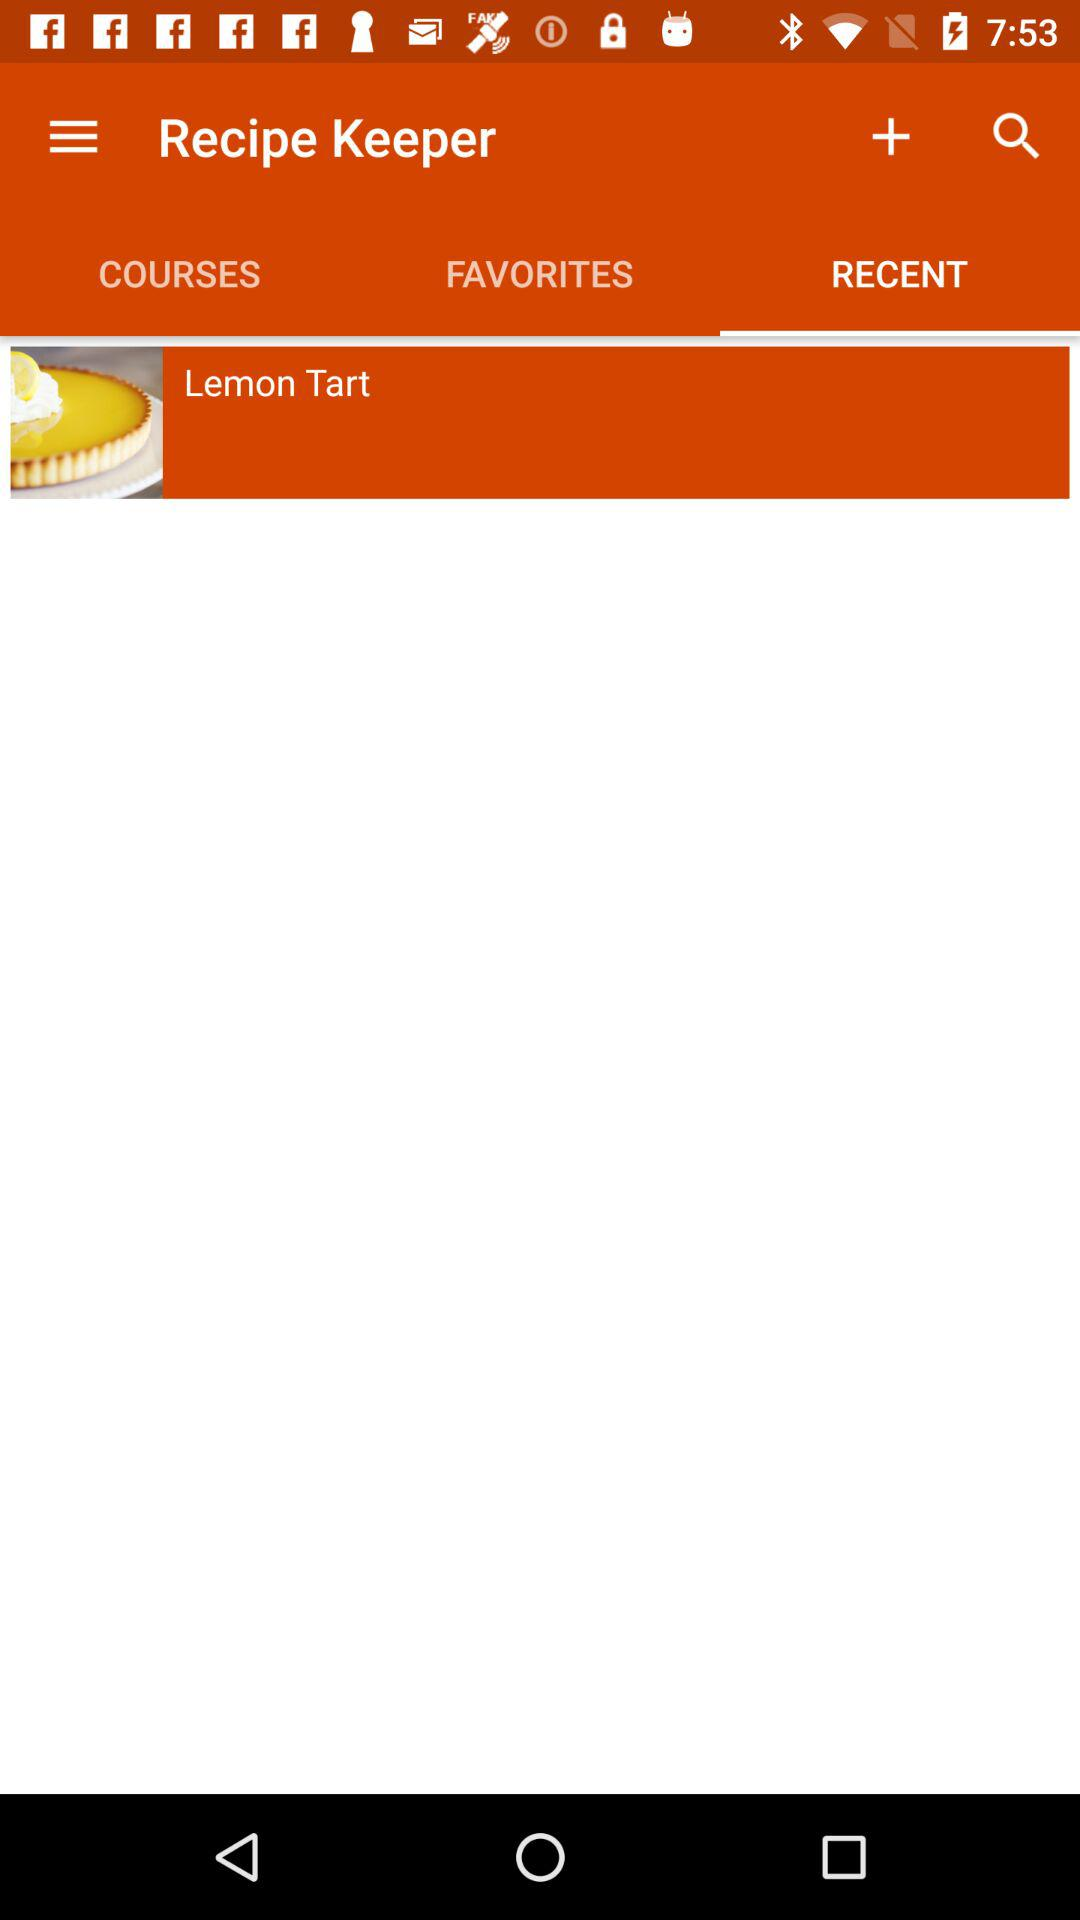What is the selected tab? The selected tab is "RECENT". 